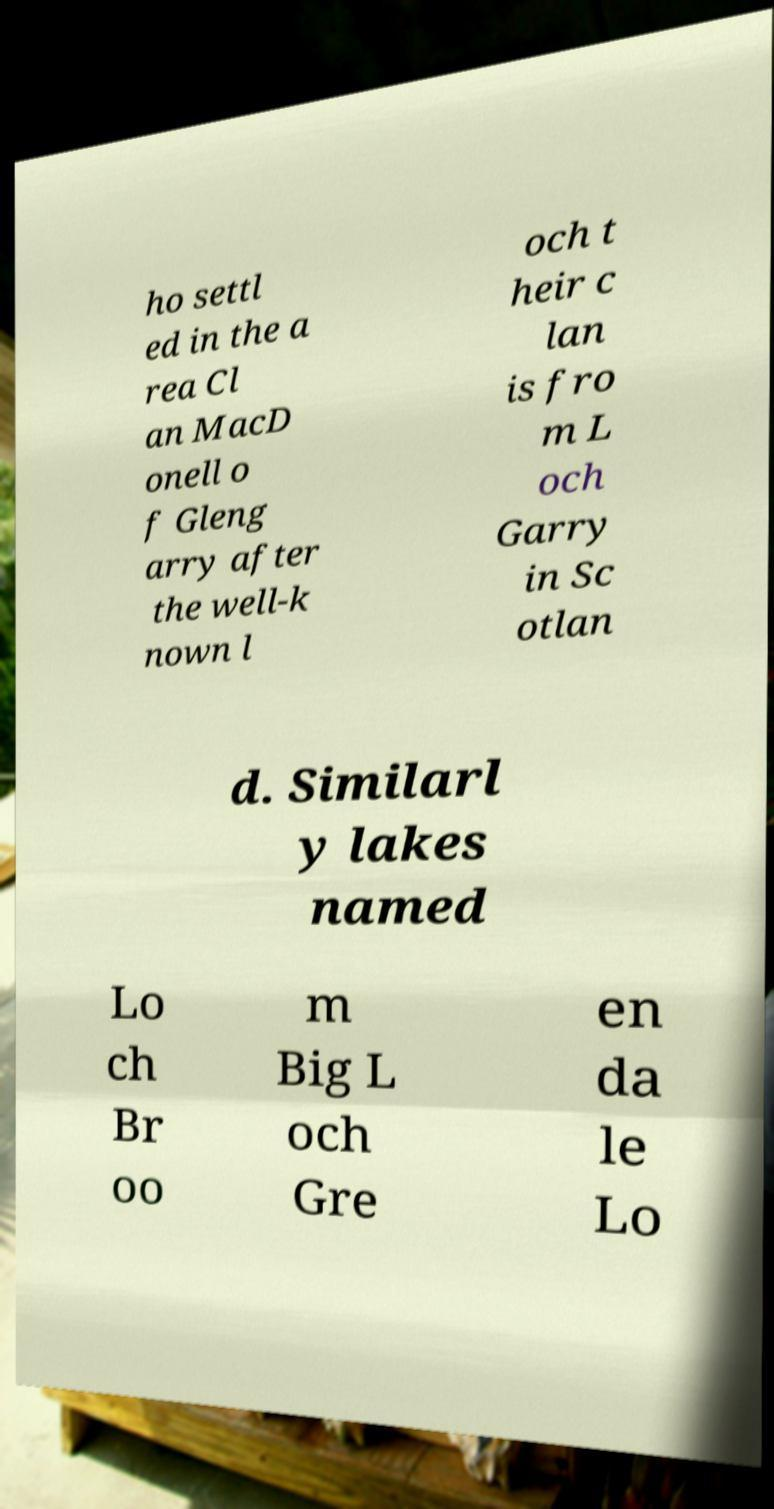Please identify and transcribe the text found in this image. ho settl ed in the a rea Cl an MacD onell o f Gleng arry after the well-k nown l och t heir c lan is fro m L och Garry in Sc otlan d. Similarl y lakes named Lo ch Br oo m Big L och Gre en da le Lo 